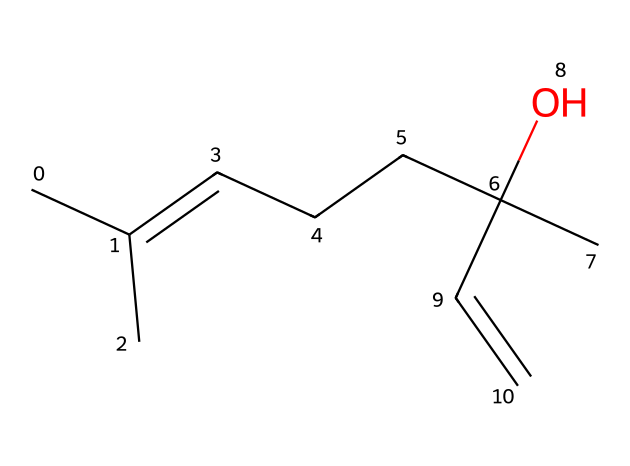What is the molecular formula of linalool? By analyzing the SMILES representation, we identify the atoms present: there are 10 carbon atoms (C), 18 hydrogen atoms (H), and 1 oxygen atom (O). Therefore, the molecular formula is derived from the count of each type of atom.
Answer: C10H18O How many double bonds are present in linalool? Examining the structure indicated by the SMILES notation, we observe one double bond in the chain (C=C), leading to the conclusion that it has a single double bond.
Answer: 1 What functional group is present in linalool? The presence of the -OH group in the structure identifies it as an alcohol functional group. By looking at the oxygen atom's connectivity in the SMILES, we can confirm it is a tertiary alcohol.
Answer: alcohol What is the carbon chain length of linalool? By reviewing the SMILES, we count the number of carbon atoms in the longest continuous sequence, which amounts to 10. Hence, the carbon chain length is determined to be 10 carbon atoms.
Answer: 10 Is linalool a saturated or unsaturated compound? The presence of a double bond (C=C) in the structure indicates that linalool is unsaturated. The identification of this feature confirms that it cannot be fully saturated with hydrogen atoms.
Answer: unsaturated What type of terpene is linalool? Considering both its structure and the fact it contains an alcohol functional group, linalool is classified as a monoterpene alcoholic. This classification is based on the number of carbon atoms (ten) and the specific functional groups it contains.
Answer: monoterpene alcoholic 